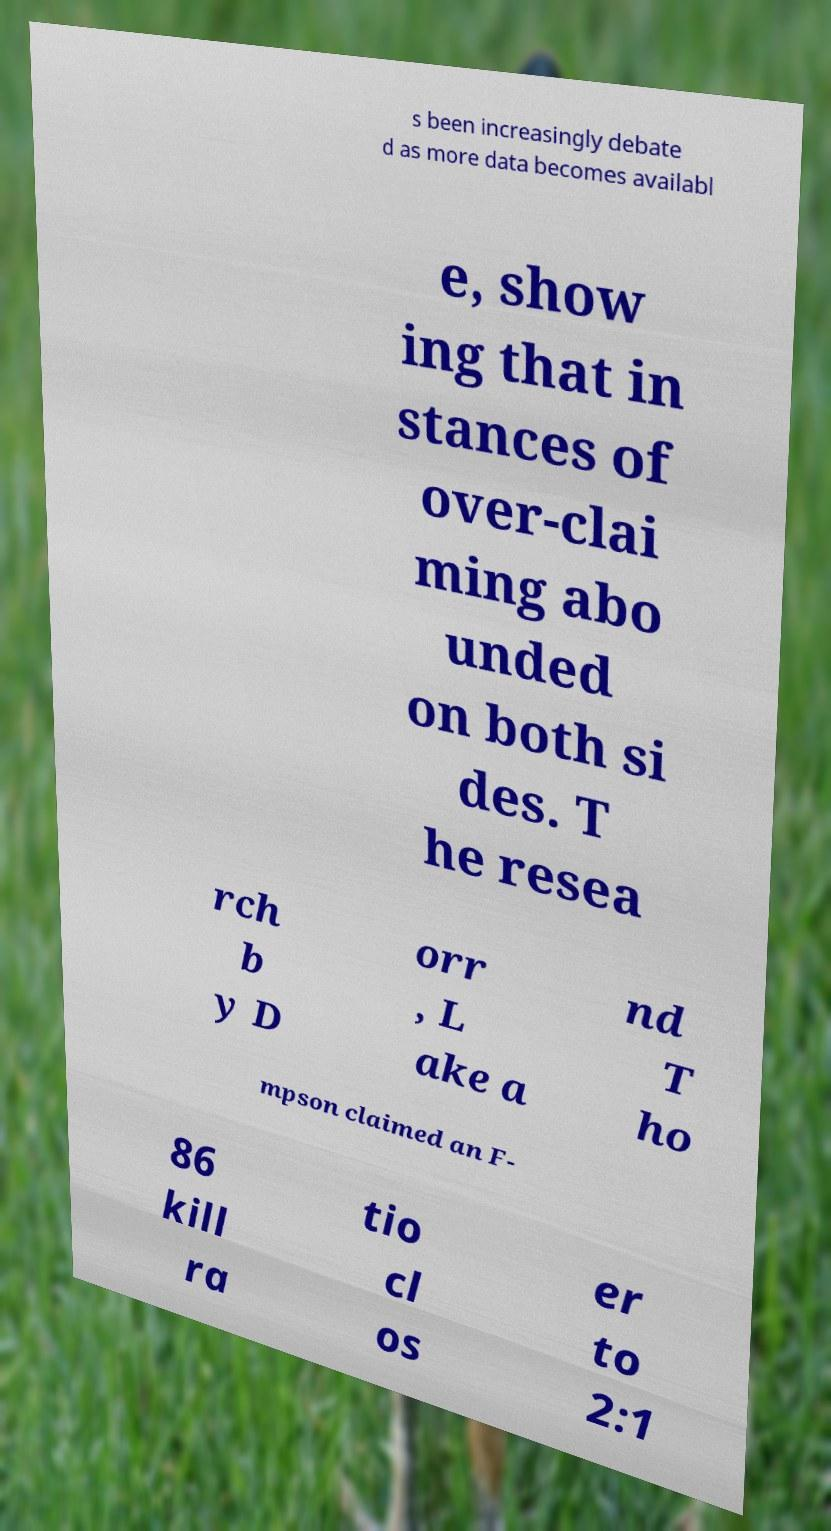Can you accurately transcribe the text from the provided image for me? s been increasingly debate d as more data becomes availabl e, show ing that in stances of over-clai ming abo unded on both si des. T he resea rch b y D orr , L ake a nd T ho mpson claimed an F- 86 kill ra tio cl os er to 2:1 